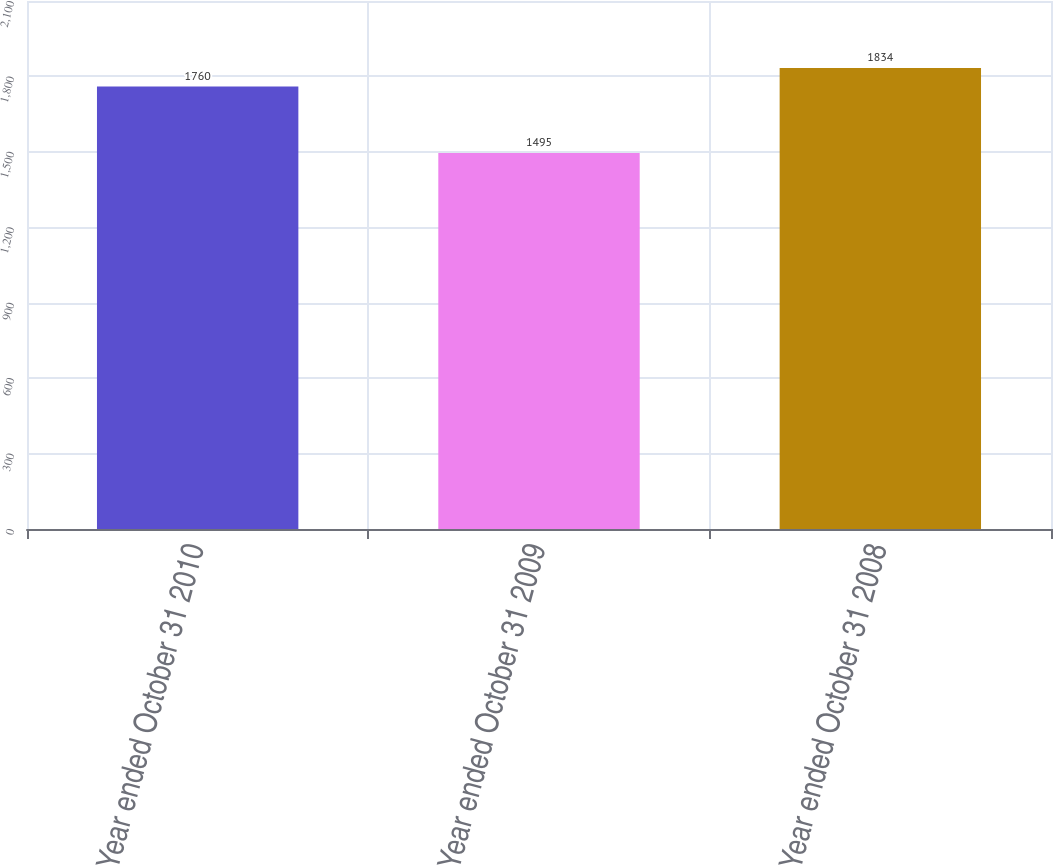Convert chart. <chart><loc_0><loc_0><loc_500><loc_500><bar_chart><fcel>Year ended October 31 2010<fcel>Year ended October 31 2009<fcel>Year ended October 31 2008<nl><fcel>1760<fcel>1495<fcel>1834<nl></chart> 